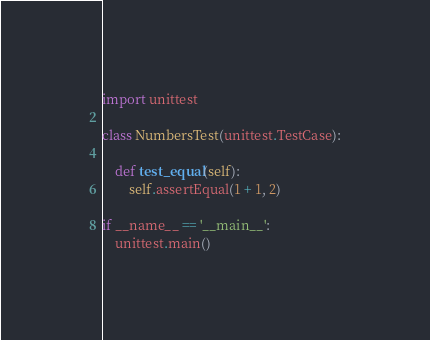<code> <loc_0><loc_0><loc_500><loc_500><_Python_>import unittest

class NumbersTest(unittest.TestCase):

    def test_equal(self):
        self.assertEqual(1 + 1, 2)

if __name__ == '__main__':
    unittest.main()
</code> 